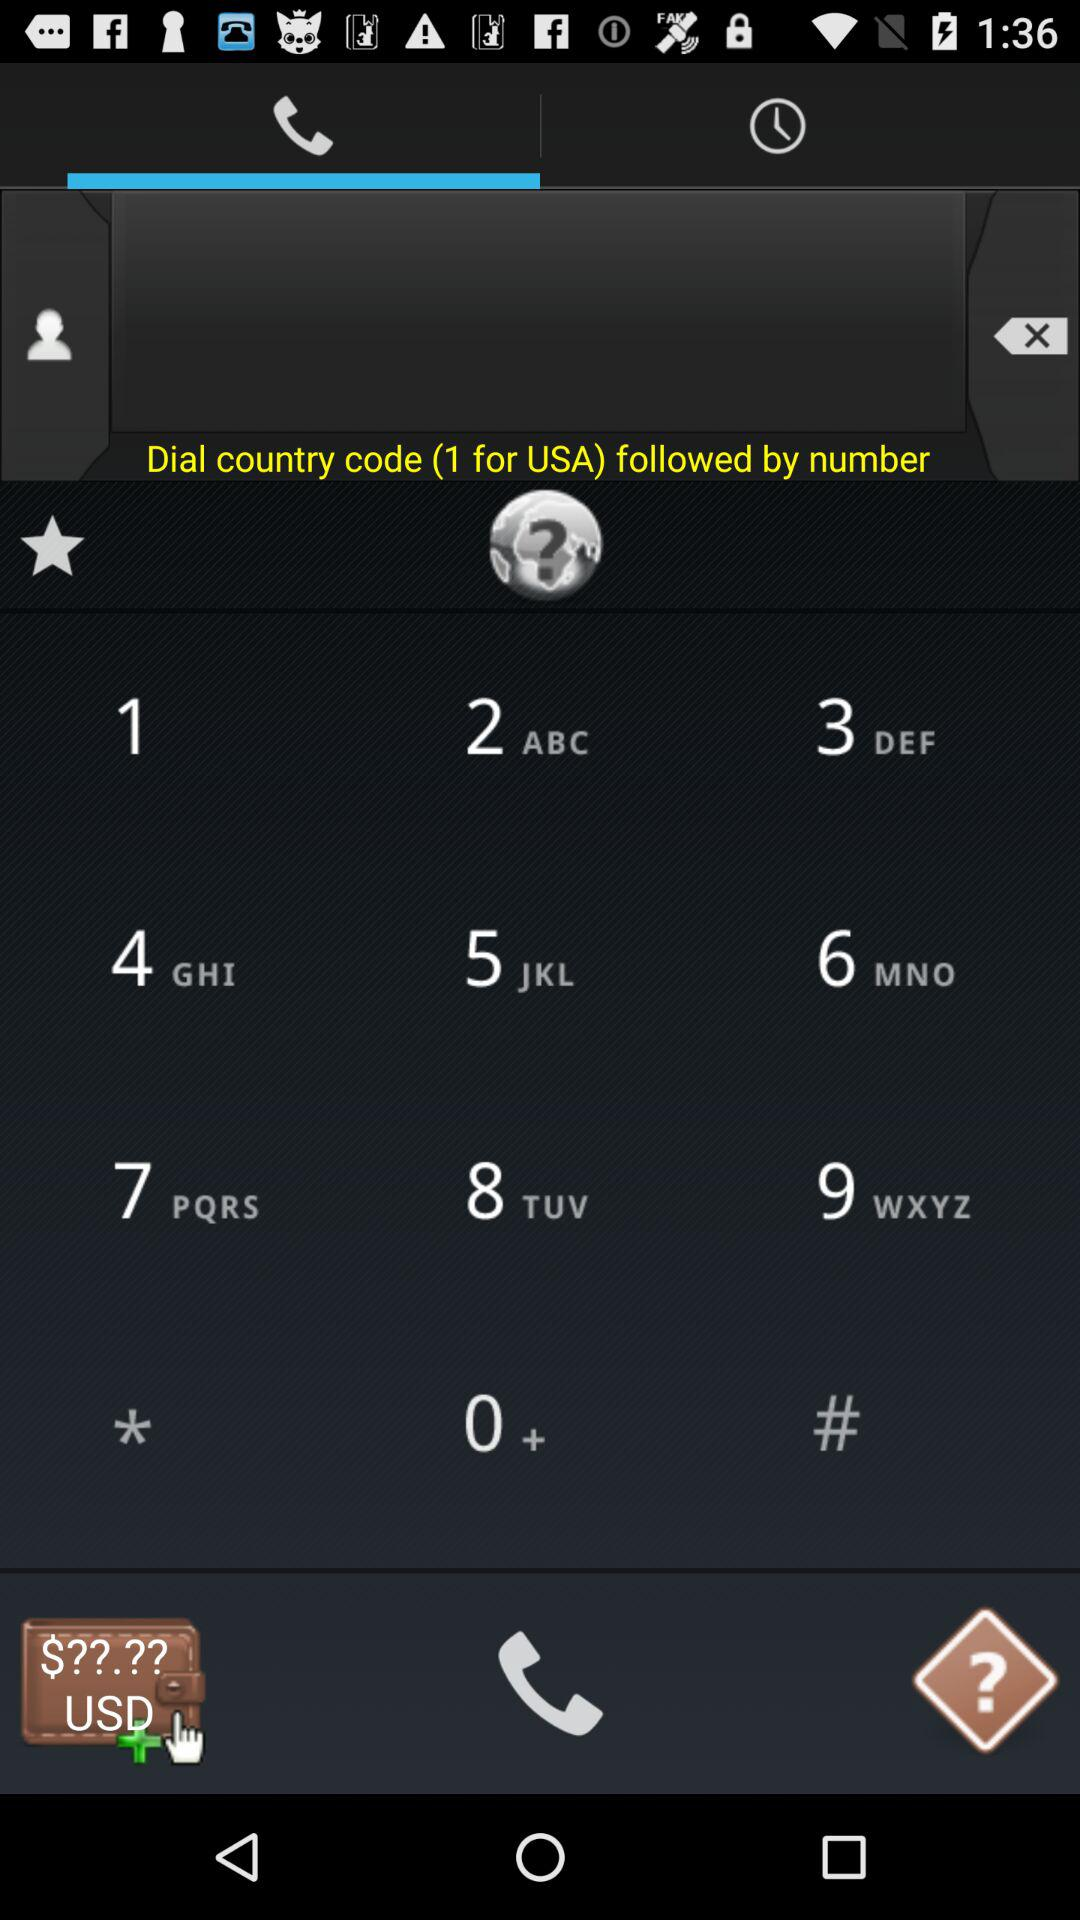What is the country code for the USA? The country code for the USA is 1. 